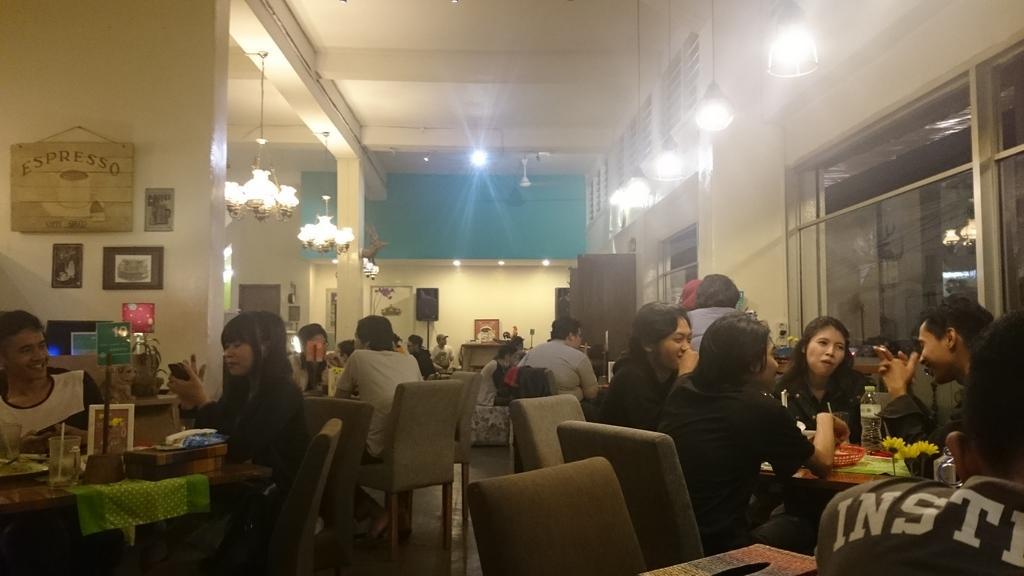Please provide a concise description of this image. In this image, there are some persons sitting on the chair. There is table in front of these persons. This table contains a water bottle. There is an another table contains a glass. There is a speaker and photo frame attached to the wall. On the top there is a light and fan. 